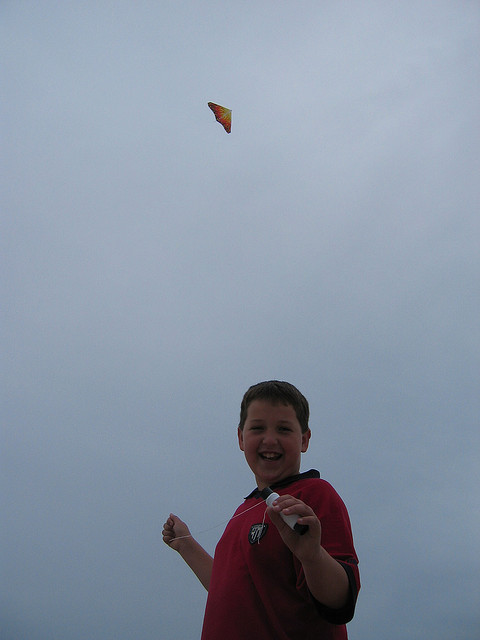<image>What kind of tie is the bear wearing? The bear is not wearing a tie. It might not even be a bear in the image. What is the man carrying? I don't know what the man is carrying. It could be a kite or a string. What kind of tie is the bear wearing? I don't know what kind of tie the bear is wearing. It seems like there is no tie on the bear. What is the man carrying? I don't know what the man is carrying. It could be a kite or a string. 